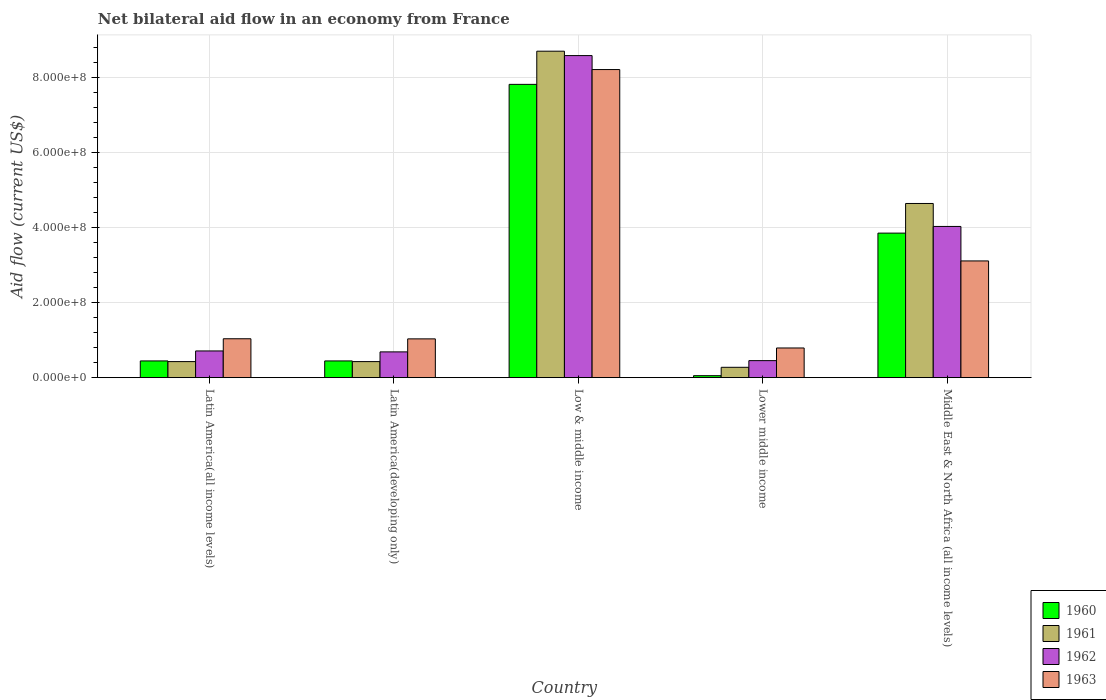How many groups of bars are there?
Offer a terse response. 5. How many bars are there on the 3rd tick from the left?
Offer a terse response. 4. How many bars are there on the 2nd tick from the right?
Your response must be concise. 4. What is the label of the 1st group of bars from the left?
Provide a succinct answer. Latin America(all income levels). In how many cases, is the number of bars for a given country not equal to the number of legend labels?
Provide a short and direct response. 0. What is the net bilateral aid flow in 1962 in Latin America(all income levels)?
Provide a succinct answer. 7.12e+07. Across all countries, what is the maximum net bilateral aid flow in 1960?
Give a very brief answer. 7.82e+08. Across all countries, what is the minimum net bilateral aid flow in 1962?
Provide a short and direct response. 4.54e+07. In which country was the net bilateral aid flow in 1960 maximum?
Offer a terse response. Low & middle income. In which country was the net bilateral aid flow in 1960 minimum?
Provide a short and direct response. Lower middle income. What is the total net bilateral aid flow in 1961 in the graph?
Offer a very short reply. 1.45e+09. What is the difference between the net bilateral aid flow in 1960 in Lower middle income and that in Middle East & North Africa (all income levels)?
Your answer should be compact. -3.80e+08. What is the difference between the net bilateral aid flow in 1963 in Low & middle income and the net bilateral aid flow in 1961 in Middle East & North Africa (all income levels)?
Offer a terse response. 3.57e+08. What is the average net bilateral aid flow in 1960 per country?
Make the answer very short. 2.52e+08. What is the difference between the net bilateral aid flow of/in 1963 and net bilateral aid flow of/in 1960 in Latin America(all income levels)?
Your response must be concise. 5.91e+07. What is the ratio of the net bilateral aid flow in 1961 in Latin America(developing only) to that in Middle East & North Africa (all income levels)?
Your answer should be very brief. 0.09. What is the difference between the highest and the second highest net bilateral aid flow in 1960?
Offer a terse response. 3.96e+08. What is the difference between the highest and the lowest net bilateral aid flow in 1963?
Your answer should be compact. 7.42e+08. In how many countries, is the net bilateral aid flow in 1962 greater than the average net bilateral aid flow in 1962 taken over all countries?
Make the answer very short. 2. Is the sum of the net bilateral aid flow in 1961 in Low & middle income and Middle East & North Africa (all income levels) greater than the maximum net bilateral aid flow in 1960 across all countries?
Ensure brevity in your answer.  Yes. Is it the case that in every country, the sum of the net bilateral aid flow in 1961 and net bilateral aid flow in 1960 is greater than the sum of net bilateral aid flow in 1962 and net bilateral aid flow in 1963?
Provide a succinct answer. No. What does the 3rd bar from the left in Lower middle income represents?
Your response must be concise. 1962. Are all the bars in the graph horizontal?
Offer a terse response. No. How many countries are there in the graph?
Give a very brief answer. 5. What is the difference between two consecutive major ticks on the Y-axis?
Your response must be concise. 2.00e+08. Does the graph contain any zero values?
Provide a succinct answer. No. Where does the legend appear in the graph?
Ensure brevity in your answer.  Bottom right. How are the legend labels stacked?
Offer a terse response. Vertical. What is the title of the graph?
Offer a terse response. Net bilateral aid flow in an economy from France. What is the Aid flow (current US$) of 1960 in Latin America(all income levels)?
Offer a terse response. 4.46e+07. What is the Aid flow (current US$) of 1961 in Latin America(all income levels)?
Your answer should be compact. 4.28e+07. What is the Aid flow (current US$) of 1962 in Latin America(all income levels)?
Your response must be concise. 7.12e+07. What is the Aid flow (current US$) in 1963 in Latin America(all income levels)?
Offer a very short reply. 1.04e+08. What is the Aid flow (current US$) of 1960 in Latin America(developing only)?
Give a very brief answer. 4.46e+07. What is the Aid flow (current US$) of 1961 in Latin America(developing only)?
Offer a terse response. 4.28e+07. What is the Aid flow (current US$) in 1962 in Latin America(developing only)?
Make the answer very short. 6.87e+07. What is the Aid flow (current US$) in 1963 in Latin America(developing only)?
Keep it short and to the point. 1.03e+08. What is the Aid flow (current US$) in 1960 in Low & middle income?
Provide a short and direct response. 7.82e+08. What is the Aid flow (current US$) in 1961 in Low & middle income?
Provide a short and direct response. 8.70e+08. What is the Aid flow (current US$) of 1962 in Low & middle income?
Provide a succinct answer. 8.58e+08. What is the Aid flow (current US$) in 1963 in Low & middle income?
Provide a succinct answer. 8.21e+08. What is the Aid flow (current US$) in 1960 in Lower middle income?
Give a very brief answer. 5.30e+06. What is the Aid flow (current US$) of 1961 in Lower middle income?
Your answer should be compact. 2.76e+07. What is the Aid flow (current US$) in 1962 in Lower middle income?
Offer a very short reply. 4.54e+07. What is the Aid flow (current US$) in 1963 in Lower middle income?
Your response must be concise. 7.91e+07. What is the Aid flow (current US$) in 1960 in Middle East & North Africa (all income levels)?
Provide a short and direct response. 3.85e+08. What is the Aid flow (current US$) in 1961 in Middle East & North Africa (all income levels)?
Keep it short and to the point. 4.64e+08. What is the Aid flow (current US$) in 1962 in Middle East & North Africa (all income levels)?
Your answer should be very brief. 4.03e+08. What is the Aid flow (current US$) in 1963 in Middle East & North Africa (all income levels)?
Offer a terse response. 3.11e+08. Across all countries, what is the maximum Aid flow (current US$) in 1960?
Give a very brief answer. 7.82e+08. Across all countries, what is the maximum Aid flow (current US$) in 1961?
Make the answer very short. 8.70e+08. Across all countries, what is the maximum Aid flow (current US$) in 1962?
Give a very brief answer. 8.58e+08. Across all countries, what is the maximum Aid flow (current US$) in 1963?
Ensure brevity in your answer.  8.21e+08. Across all countries, what is the minimum Aid flow (current US$) in 1960?
Keep it short and to the point. 5.30e+06. Across all countries, what is the minimum Aid flow (current US$) in 1961?
Provide a short and direct response. 2.76e+07. Across all countries, what is the minimum Aid flow (current US$) in 1962?
Provide a short and direct response. 4.54e+07. Across all countries, what is the minimum Aid flow (current US$) in 1963?
Offer a terse response. 7.91e+07. What is the total Aid flow (current US$) of 1960 in the graph?
Offer a terse response. 1.26e+09. What is the total Aid flow (current US$) in 1961 in the graph?
Your answer should be compact. 1.45e+09. What is the total Aid flow (current US$) in 1962 in the graph?
Your response must be concise. 1.45e+09. What is the total Aid flow (current US$) in 1963 in the graph?
Your answer should be compact. 1.42e+09. What is the difference between the Aid flow (current US$) in 1960 in Latin America(all income levels) and that in Latin America(developing only)?
Your response must be concise. 0. What is the difference between the Aid flow (current US$) of 1961 in Latin America(all income levels) and that in Latin America(developing only)?
Your response must be concise. 0. What is the difference between the Aid flow (current US$) in 1962 in Latin America(all income levels) and that in Latin America(developing only)?
Your response must be concise. 2.50e+06. What is the difference between the Aid flow (current US$) of 1960 in Latin America(all income levels) and that in Low & middle income?
Your answer should be compact. -7.37e+08. What is the difference between the Aid flow (current US$) of 1961 in Latin America(all income levels) and that in Low & middle income?
Provide a succinct answer. -8.27e+08. What is the difference between the Aid flow (current US$) in 1962 in Latin America(all income levels) and that in Low & middle income?
Make the answer very short. -7.87e+08. What is the difference between the Aid flow (current US$) of 1963 in Latin America(all income levels) and that in Low & middle income?
Provide a short and direct response. -7.17e+08. What is the difference between the Aid flow (current US$) of 1960 in Latin America(all income levels) and that in Lower middle income?
Ensure brevity in your answer.  3.93e+07. What is the difference between the Aid flow (current US$) in 1961 in Latin America(all income levels) and that in Lower middle income?
Make the answer very short. 1.52e+07. What is the difference between the Aid flow (current US$) of 1962 in Latin America(all income levels) and that in Lower middle income?
Ensure brevity in your answer.  2.58e+07. What is the difference between the Aid flow (current US$) in 1963 in Latin America(all income levels) and that in Lower middle income?
Your answer should be very brief. 2.46e+07. What is the difference between the Aid flow (current US$) of 1960 in Latin America(all income levels) and that in Middle East & North Africa (all income levels)?
Your answer should be very brief. -3.41e+08. What is the difference between the Aid flow (current US$) of 1961 in Latin America(all income levels) and that in Middle East & North Africa (all income levels)?
Offer a very short reply. -4.21e+08. What is the difference between the Aid flow (current US$) of 1962 in Latin America(all income levels) and that in Middle East & North Africa (all income levels)?
Your answer should be compact. -3.32e+08. What is the difference between the Aid flow (current US$) in 1963 in Latin America(all income levels) and that in Middle East & North Africa (all income levels)?
Your answer should be compact. -2.07e+08. What is the difference between the Aid flow (current US$) in 1960 in Latin America(developing only) and that in Low & middle income?
Your answer should be compact. -7.37e+08. What is the difference between the Aid flow (current US$) in 1961 in Latin America(developing only) and that in Low & middle income?
Ensure brevity in your answer.  -8.27e+08. What is the difference between the Aid flow (current US$) in 1962 in Latin America(developing only) and that in Low & middle income?
Offer a very short reply. -7.90e+08. What is the difference between the Aid flow (current US$) in 1963 in Latin America(developing only) and that in Low & middle income?
Your answer should be very brief. -7.18e+08. What is the difference between the Aid flow (current US$) in 1960 in Latin America(developing only) and that in Lower middle income?
Give a very brief answer. 3.93e+07. What is the difference between the Aid flow (current US$) in 1961 in Latin America(developing only) and that in Lower middle income?
Your answer should be compact. 1.52e+07. What is the difference between the Aid flow (current US$) in 1962 in Latin America(developing only) and that in Lower middle income?
Provide a succinct answer. 2.33e+07. What is the difference between the Aid flow (current US$) in 1963 in Latin America(developing only) and that in Lower middle income?
Give a very brief answer. 2.43e+07. What is the difference between the Aid flow (current US$) in 1960 in Latin America(developing only) and that in Middle East & North Africa (all income levels)?
Provide a short and direct response. -3.41e+08. What is the difference between the Aid flow (current US$) in 1961 in Latin America(developing only) and that in Middle East & North Africa (all income levels)?
Make the answer very short. -4.21e+08. What is the difference between the Aid flow (current US$) in 1962 in Latin America(developing only) and that in Middle East & North Africa (all income levels)?
Your answer should be compact. -3.34e+08. What is the difference between the Aid flow (current US$) of 1963 in Latin America(developing only) and that in Middle East & North Africa (all income levels)?
Offer a terse response. -2.08e+08. What is the difference between the Aid flow (current US$) of 1960 in Low & middle income and that in Lower middle income?
Offer a terse response. 7.76e+08. What is the difference between the Aid flow (current US$) in 1961 in Low & middle income and that in Lower middle income?
Offer a very short reply. 8.42e+08. What is the difference between the Aid flow (current US$) in 1962 in Low & middle income and that in Lower middle income?
Your answer should be very brief. 8.13e+08. What is the difference between the Aid flow (current US$) in 1963 in Low & middle income and that in Lower middle income?
Ensure brevity in your answer.  7.42e+08. What is the difference between the Aid flow (current US$) in 1960 in Low & middle income and that in Middle East & North Africa (all income levels)?
Provide a short and direct response. 3.96e+08. What is the difference between the Aid flow (current US$) in 1961 in Low & middle income and that in Middle East & North Africa (all income levels)?
Make the answer very short. 4.06e+08. What is the difference between the Aid flow (current US$) in 1962 in Low & middle income and that in Middle East & North Africa (all income levels)?
Give a very brief answer. 4.55e+08. What is the difference between the Aid flow (current US$) of 1963 in Low & middle income and that in Middle East & North Africa (all income levels)?
Provide a succinct answer. 5.10e+08. What is the difference between the Aid flow (current US$) of 1960 in Lower middle income and that in Middle East & North Africa (all income levels)?
Provide a short and direct response. -3.80e+08. What is the difference between the Aid flow (current US$) in 1961 in Lower middle income and that in Middle East & North Africa (all income levels)?
Offer a very short reply. -4.37e+08. What is the difference between the Aid flow (current US$) in 1962 in Lower middle income and that in Middle East & North Africa (all income levels)?
Your response must be concise. -3.58e+08. What is the difference between the Aid flow (current US$) in 1963 in Lower middle income and that in Middle East & North Africa (all income levels)?
Your answer should be compact. -2.32e+08. What is the difference between the Aid flow (current US$) in 1960 in Latin America(all income levels) and the Aid flow (current US$) in 1961 in Latin America(developing only)?
Provide a succinct answer. 1.80e+06. What is the difference between the Aid flow (current US$) of 1960 in Latin America(all income levels) and the Aid flow (current US$) of 1962 in Latin America(developing only)?
Your answer should be very brief. -2.41e+07. What is the difference between the Aid flow (current US$) in 1960 in Latin America(all income levels) and the Aid flow (current US$) in 1963 in Latin America(developing only)?
Your answer should be compact. -5.88e+07. What is the difference between the Aid flow (current US$) in 1961 in Latin America(all income levels) and the Aid flow (current US$) in 1962 in Latin America(developing only)?
Ensure brevity in your answer.  -2.59e+07. What is the difference between the Aid flow (current US$) in 1961 in Latin America(all income levels) and the Aid flow (current US$) in 1963 in Latin America(developing only)?
Make the answer very short. -6.06e+07. What is the difference between the Aid flow (current US$) in 1962 in Latin America(all income levels) and the Aid flow (current US$) in 1963 in Latin America(developing only)?
Keep it short and to the point. -3.22e+07. What is the difference between the Aid flow (current US$) in 1960 in Latin America(all income levels) and the Aid flow (current US$) in 1961 in Low & middle income?
Your answer should be very brief. -8.25e+08. What is the difference between the Aid flow (current US$) of 1960 in Latin America(all income levels) and the Aid flow (current US$) of 1962 in Low & middle income?
Keep it short and to the point. -8.14e+08. What is the difference between the Aid flow (current US$) of 1960 in Latin America(all income levels) and the Aid flow (current US$) of 1963 in Low & middle income?
Provide a succinct answer. -7.76e+08. What is the difference between the Aid flow (current US$) in 1961 in Latin America(all income levels) and the Aid flow (current US$) in 1962 in Low & middle income?
Keep it short and to the point. -8.16e+08. What is the difference between the Aid flow (current US$) in 1961 in Latin America(all income levels) and the Aid flow (current US$) in 1963 in Low & middle income?
Provide a short and direct response. -7.78e+08. What is the difference between the Aid flow (current US$) in 1962 in Latin America(all income levels) and the Aid flow (current US$) in 1963 in Low & middle income?
Give a very brief answer. -7.50e+08. What is the difference between the Aid flow (current US$) of 1960 in Latin America(all income levels) and the Aid flow (current US$) of 1961 in Lower middle income?
Your response must be concise. 1.70e+07. What is the difference between the Aid flow (current US$) in 1960 in Latin America(all income levels) and the Aid flow (current US$) in 1962 in Lower middle income?
Make the answer very short. -8.00e+05. What is the difference between the Aid flow (current US$) of 1960 in Latin America(all income levels) and the Aid flow (current US$) of 1963 in Lower middle income?
Provide a short and direct response. -3.45e+07. What is the difference between the Aid flow (current US$) in 1961 in Latin America(all income levels) and the Aid flow (current US$) in 1962 in Lower middle income?
Offer a very short reply. -2.60e+06. What is the difference between the Aid flow (current US$) of 1961 in Latin America(all income levels) and the Aid flow (current US$) of 1963 in Lower middle income?
Your response must be concise. -3.63e+07. What is the difference between the Aid flow (current US$) of 1962 in Latin America(all income levels) and the Aid flow (current US$) of 1963 in Lower middle income?
Keep it short and to the point. -7.90e+06. What is the difference between the Aid flow (current US$) of 1960 in Latin America(all income levels) and the Aid flow (current US$) of 1961 in Middle East & North Africa (all income levels)?
Keep it short and to the point. -4.20e+08. What is the difference between the Aid flow (current US$) in 1960 in Latin America(all income levels) and the Aid flow (current US$) in 1962 in Middle East & North Africa (all income levels)?
Make the answer very short. -3.58e+08. What is the difference between the Aid flow (current US$) of 1960 in Latin America(all income levels) and the Aid flow (current US$) of 1963 in Middle East & North Africa (all income levels)?
Make the answer very short. -2.66e+08. What is the difference between the Aid flow (current US$) of 1961 in Latin America(all income levels) and the Aid flow (current US$) of 1962 in Middle East & North Africa (all income levels)?
Offer a terse response. -3.60e+08. What is the difference between the Aid flow (current US$) of 1961 in Latin America(all income levels) and the Aid flow (current US$) of 1963 in Middle East & North Africa (all income levels)?
Provide a short and direct response. -2.68e+08. What is the difference between the Aid flow (current US$) in 1962 in Latin America(all income levels) and the Aid flow (current US$) in 1963 in Middle East & North Africa (all income levels)?
Offer a terse response. -2.40e+08. What is the difference between the Aid flow (current US$) in 1960 in Latin America(developing only) and the Aid flow (current US$) in 1961 in Low & middle income?
Give a very brief answer. -8.25e+08. What is the difference between the Aid flow (current US$) of 1960 in Latin America(developing only) and the Aid flow (current US$) of 1962 in Low & middle income?
Offer a very short reply. -8.14e+08. What is the difference between the Aid flow (current US$) in 1960 in Latin America(developing only) and the Aid flow (current US$) in 1963 in Low & middle income?
Offer a terse response. -7.76e+08. What is the difference between the Aid flow (current US$) in 1961 in Latin America(developing only) and the Aid flow (current US$) in 1962 in Low & middle income?
Keep it short and to the point. -8.16e+08. What is the difference between the Aid flow (current US$) of 1961 in Latin America(developing only) and the Aid flow (current US$) of 1963 in Low & middle income?
Your answer should be very brief. -7.78e+08. What is the difference between the Aid flow (current US$) in 1962 in Latin America(developing only) and the Aid flow (current US$) in 1963 in Low & middle income?
Your answer should be very brief. -7.52e+08. What is the difference between the Aid flow (current US$) of 1960 in Latin America(developing only) and the Aid flow (current US$) of 1961 in Lower middle income?
Provide a succinct answer. 1.70e+07. What is the difference between the Aid flow (current US$) of 1960 in Latin America(developing only) and the Aid flow (current US$) of 1962 in Lower middle income?
Keep it short and to the point. -8.00e+05. What is the difference between the Aid flow (current US$) of 1960 in Latin America(developing only) and the Aid flow (current US$) of 1963 in Lower middle income?
Your answer should be very brief. -3.45e+07. What is the difference between the Aid flow (current US$) of 1961 in Latin America(developing only) and the Aid flow (current US$) of 1962 in Lower middle income?
Provide a succinct answer. -2.60e+06. What is the difference between the Aid flow (current US$) of 1961 in Latin America(developing only) and the Aid flow (current US$) of 1963 in Lower middle income?
Ensure brevity in your answer.  -3.63e+07. What is the difference between the Aid flow (current US$) of 1962 in Latin America(developing only) and the Aid flow (current US$) of 1963 in Lower middle income?
Your answer should be very brief. -1.04e+07. What is the difference between the Aid flow (current US$) of 1960 in Latin America(developing only) and the Aid flow (current US$) of 1961 in Middle East & North Africa (all income levels)?
Offer a very short reply. -4.20e+08. What is the difference between the Aid flow (current US$) in 1960 in Latin America(developing only) and the Aid flow (current US$) in 1962 in Middle East & North Africa (all income levels)?
Keep it short and to the point. -3.58e+08. What is the difference between the Aid flow (current US$) of 1960 in Latin America(developing only) and the Aid flow (current US$) of 1963 in Middle East & North Africa (all income levels)?
Give a very brief answer. -2.66e+08. What is the difference between the Aid flow (current US$) in 1961 in Latin America(developing only) and the Aid flow (current US$) in 1962 in Middle East & North Africa (all income levels)?
Your answer should be very brief. -3.60e+08. What is the difference between the Aid flow (current US$) of 1961 in Latin America(developing only) and the Aid flow (current US$) of 1963 in Middle East & North Africa (all income levels)?
Provide a succinct answer. -2.68e+08. What is the difference between the Aid flow (current US$) of 1962 in Latin America(developing only) and the Aid flow (current US$) of 1963 in Middle East & North Africa (all income levels)?
Ensure brevity in your answer.  -2.42e+08. What is the difference between the Aid flow (current US$) of 1960 in Low & middle income and the Aid flow (current US$) of 1961 in Lower middle income?
Your response must be concise. 7.54e+08. What is the difference between the Aid flow (current US$) in 1960 in Low & middle income and the Aid flow (current US$) in 1962 in Lower middle income?
Give a very brief answer. 7.36e+08. What is the difference between the Aid flow (current US$) in 1960 in Low & middle income and the Aid flow (current US$) in 1963 in Lower middle income?
Your response must be concise. 7.02e+08. What is the difference between the Aid flow (current US$) in 1961 in Low & middle income and the Aid flow (current US$) in 1962 in Lower middle income?
Your response must be concise. 8.25e+08. What is the difference between the Aid flow (current US$) of 1961 in Low & middle income and the Aid flow (current US$) of 1963 in Lower middle income?
Offer a very short reply. 7.91e+08. What is the difference between the Aid flow (current US$) of 1962 in Low & middle income and the Aid flow (current US$) of 1963 in Lower middle income?
Keep it short and to the point. 7.79e+08. What is the difference between the Aid flow (current US$) in 1960 in Low & middle income and the Aid flow (current US$) in 1961 in Middle East & North Africa (all income levels)?
Provide a succinct answer. 3.17e+08. What is the difference between the Aid flow (current US$) in 1960 in Low & middle income and the Aid flow (current US$) in 1962 in Middle East & North Africa (all income levels)?
Offer a very short reply. 3.79e+08. What is the difference between the Aid flow (current US$) of 1960 in Low & middle income and the Aid flow (current US$) of 1963 in Middle East & North Africa (all income levels)?
Your answer should be compact. 4.70e+08. What is the difference between the Aid flow (current US$) in 1961 in Low & middle income and the Aid flow (current US$) in 1962 in Middle East & North Africa (all income levels)?
Your response must be concise. 4.67e+08. What is the difference between the Aid flow (current US$) in 1961 in Low & middle income and the Aid flow (current US$) in 1963 in Middle East & North Africa (all income levels)?
Offer a very short reply. 5.59e+08. What is the difference between the Aid flow (current US$) of 1962 in Low & middle income and the Aid flow (current US$) of 1963 in Middle East & North Africa (all income levels)?
Your response must be concise. 5.47e+08. What is the difference between the Aid flow (current US$) of 1960 in Lower middle income and the Aid flow (current US$) of 1961 in Middle East & North Africa (all income levels)?
Ensure brevity in your answer.  -4.59e+08. What is the difference between the Aid flow (current US$) of 1960 in Lower middle income and the Aid flow (current US$) of 1962 in Middle East & North Africa (all income levels)?
Ensure brevity in your answer.  -3.98e+08. What is the difference between the Aid flow (current US$) of 1960 in Lower middle income and the Aid flow (current US$) of 1963 in Middle East & North Africa (all income levels)?
Provide a short and direct response. -3.06e+08. What is the difference between the Aid flow (current US$) of 1961 in Lower middle income and the Aid flow (current US$) of 1962 in Middle East & North Africa (all income levels)?
Your answer should be very brief. -3.75e+08. What is the difference between the Aid flow (current US$) in 1961 in Lower middle income and the Aid flow (current US$) in 1963 in Middle East & North Africa (all income levels)?
Offer a terse response. -2.84e+08. What is the difference between the Aid flow (current US$) of 1962 in Lower middle income and the Aid flow (current US$) of 1963 in Middle East & North Africa (all income levels)?
Give a very brief answer. -2.66e+08. What is the average Aid flow (current US$) of 1960 per country?
Your answer should be very brief. 2.52e+08. What is the average Aid flow (current US$) of 1961 per country?
Provide a succinct answer. 2.89e+08. What is the average Aid flow (current US$) in 1962 per country?
Provide a short and direct response. 2.89e+08. What is the average Aid flow (current US$) in 1963 per country?
Provide a succinct answer. 2.84e+08. What is the difference between the Aid flow (current US$) in 1960 and Aid flow (current US$) in 1961 in Latin America(all income levels)?
Keep it short and to the point. 1.80e+06. What is the difference between the Aid flow (current US$) of 1960 and Aid flow (current US$) of 1962 in Latin America(all income levels)?
Your answer should be very brief. -2.66e+07. What is the difference between the Aid flow (current US$) in 1960 and Aid flow (current US$) in 1963 in Latin America(all income levels)?
Your response must be concise. -5.91e+07. What is the difference between the Aid flow (current US$) of 1961 and Aid flow (current US$) of 1962 in Latin America(all income levels)?
Ensure brevity in your answer.  -2.84e+07. What is the difference between the Aid flow (current US$) in 1961 and Aid flow (current US$) in 1963 in Latin America(all income levels)?
Ensure brevity in your answer.  -6.09e+07. What is the difference between the Aid flow (current US$) of 1962 and Aid flow (current US$) of 1963 in Latin America(all income levels)?
Your response must be concise. -3.25e+07. What is the difference between the Aid flow (current US$) in 1960 and Aid flow (current US$) in 1961 in Latin America(developing only)?
Give a very brief answer. 1.80e+06. What is the difference between the Aid flow (current US$) in 1960 and Aid flow (current US$) in 1962 in Latin America(developing only)?
Make the answer very short. -2.41e+07. What is the difference between the Aid flow (current US$) in 1960 and Aid flow (current US$) in 1963 in Latin America(developing only)?
Provide a short and direct response. -5.88e+07. What is the difference between the Aid flow (current US$) of 1961 and Aid flow (current US$) of 1962 in Latin America(developing only)?
Your response must be concise. -2.59e+07. What is the difference between the Aid flow (current US$) in 1961 and Aid flow (current US$) in 1963 in Latin America(developing only)?
Give a very brief answer. -6.06e+07. What is the difference between the Aid flow (current US$) in 1962 and Aid flow (current US$) in 1963 in Latin America(developing only)?
Provide a succinct answer. -3.47e+07. What is the difference between the Aid flow (current US$) of 1960 and Aid flow (current US$) of 1961 in Low & middle income?
Make the answer very short. -8.84e+07. What is the difference between the Aid flow (current US$) of 1960 and Aid flow (current US$) of 1962 in Low & middle income?
Provide a short and direct response. -7.67e+07. What is the difference between the Aid flow (current US$) of 1960 and Aid flow (current US$) of 1963 in Low & middle income?
Your answer should be compact. -3.95e+07. What is the difference between the Aid flow (current US$) in 1961 and Aid flow (current US$) in 1962 in Low & middle income?
Your answer should be compact. 1.17e+07. What is the difference between the Aid flow (current US$) in 1961 and Aid flow (current US$) in 1963 in Low & middle income?
Give a very brief answer. 4.89e+07. What is the difference between the Aid flow (current US$) in 1962 and Aid flow (current US$) in 1963 in Low & middle income?
Your response must be concise. 3.72e+07. What is the difference between the Aid flow (current US$) of 1960 and Aid flow (current US$) of 1961 in Lower middle income?
Your response must be concise. -2.23e+07. What is the difference between the Aid flow (current US$) in 1960 and Aid flow (current US$) in 1962 in Lower middle income?
Provide a succinct answer. -4.01e+07. What is the difference between the Aid flow (current US$) of 1960 and Aid flow (current US$) of 1963 in Lower middle income?
Offer a very short reply. -7.38e+07. What is the difference between the Aid flow (current US$) in 1961 and Aid flow (current US$) in 1962 in Lower middle income?
Your response must be concise. -1.78e+07. What is the difference between the Aid flow (current US$) of 1961 and Aid flow (current US$) of 1963 in Lower middle income?
Your answer should be very brief. -5.15e+07. What is the difference between the Aid flow (current US$) in 1962 and Aid flow (current US$) in 1963 in Lower middle income?
Make the answer very short. -3.37e+07. What is the difference between the Aid flow (current US$) in 1960 and Aid flow (current US$) in 1961 in Middle East & North Africa (all income levels)?
Provide a succinct answer. -7.90e+07. What is the difference between the Aid flow (current US$) of 1960 and Aid flow (current US$) of 1962 in Middle East & North Africa (all income levels)?
Offer a terse response. -1.78e+07. What is the difference between the Aid flow (current US$) of 1960 and Aid flow (current US$) of 1963 in Middle East & North Africa (all income levels)?
Offer a terse response. 7.41e+07. What is the difference between the Aid flow (current US$) of 1961 and Aid flow (current US$) of 1962 in Middle East & North Africa (all income levels)?
Keep it short and to the point. 6.12e+07. What is the difference between the Aid flow (current US$) in 1961 and Aid flow (current US$) in 1963 in Middle East & North Africa (all income levels)?
Your response must be concise. 1.53e+08. What is the difference between the Aid flow (current US$) of 1962 and Aid flow (current US$) of 1963 in Middle East & North Africa (all income levels)?
Keep it short and to the point. 9.19e+07. What is the ratio of the Aid flow (current US$) in 1962 in Latin America(all income levels) to that in Latin America(developing only)?
Your answer should be compact. 1.04. What is the ratio of the Aid flow (current US$) in 1960 in Latin America(all income levels) to that in Low & middle income?
Ensure brevity in your answer.  0.06. What is the ratio of the Aid flow (current US$) in 1961 in Latin America(all income levels) to that in Low & middle income?
Give a very brief answer. 0.05. What is the ratio of the Aid flow (current US$) of 1962 in Latin America(all income levels) to that in Low & middle income?
Provide a succinct answer. 0.08. What is the ratio of the Aid flow (current US$) of 1963 in Latin America(all income levels) to that in Low & middle income?
Make the answer very short. 0.13. What is the ratio of the Aid flow (current US$) in 1960 in Latin America(all income levels) to that in Lower middle income?
Your answer should be very brief. 8.42. What is the ratio of the Aid flow (current US$) in 1961 in Latin America(all income levels) to that in Lower middle income?
Give a very brief answer. 1.55. What is the ratio of the Aid flow (current US$) in 1962 in Latin America(all income levels) to that in Lower middle income?
Keep it short and to the point. 1.57. What is the ratio of the Aid flow (current US$) of 1963 in Latin America(all income levels) to that in Lower middle income?
Provide a short and direct response. 1.31. What is the ratio of the Aid flow (current US$) in 1960 in Latin America(all income levels) to that in Middle East & North Africa (all income levels)?
Your response must be concise. 0.12. What is the ratio of the Aid flow (current US$) of 1961 in Latin America(all income levels) to that in Middle East & North Africa (all income levels)?
Keep it short and to the point. 0.09. What is the ratio of the Aid flow (current US$) of 1962 in Latin America(all income levels) to that in Middle East & North Africa (all income levels)?
Provide a succinct answer. 0.18. What is the ratio of the Aid flow (current US$) in 1963 in Latin America(all income levels) to that in Middle East & North Africa (all income levels)?
Offer a terse response. 0.33. What is the ratio of the Aid flow (current US$) of 1960 in Latin America(developing only) to that in Low & middle income?
Offer a very short reply. 0.06. What is the ratio of the Aid flow (current US$) in 1961 in Latin America(developing only) to that in Low & middle income?
Your response must be concise. 0.05. What is the ratio of the Aid flow (current US$) in 1963 in Latin America(developing only) to that in Low & middle income?
Offer a terse response. 0.13. What is the ratio of the Aid flow (current US$) in 1960 in Latin America(developing only) to that in Lower middle income?
Your answer should be compact. 8.42. What is the ratio of the Aid flow (current US$) of 1961 in Latin America(developing only) to that in Lower middle income?
Offer a very short reply. 1.55. What is the ratio of the Aid flow (current US$) in 1962 in Latin America(developing only) to that in Lower middle income?
Your response must be concise. 1.51. What is the ratio of the Aid flow (current US$) of 1963 in Latin America(developing only) to that in Lower middle income?
Offer a very short reply. 1.31. What is the ratio of the Aid flow (current US$) of 1960 in Latin America(developing only) to that in Middle East & North Africa (all income levels)?
Offer a very short reply. 0.12. What is the ratio of the Aid flow (current US$) of 1961 in Latin America(developing only) to that in Middle East & North Africa (all income levels)?
Offer a very short reply. 0.09. What is the ratio of the Aid flow (current US$) of 1962 in Latin America(developing only) to that in Middle East & North Africa (all income levels)?
Your answer should be very brief. 0.17. What is the ratio of the Aid flow (current US$) in 1963 in Latin America(developing only) to that in Middle East & North Africa (all income levels)?
Offer a terse response. 0.33. What is the ratio of the Aid flow (current US$) of 1960 in Low & middle income to that in Lower middle income?
Provide a short and direct response. 147.47. What is the ratio of the Aid flow (current US$) in 1961 in Low & middle income to that in Lower middle income?
Your response must be concise. 31.52. What is the ratio of the Aid flow (current US$) of 1962 in Low & middle income to that in Lower middle income?
Give a very brief answer. 18.91. What is the ratio of the Aid flow (current US$) of 1963 in Low & middle income to that in Lower middle income?
Your answer should be compact. 10.38. What is the ratio of the Aid flow (current US$) of 1960 in Low & middle income to that in Middle East & North Africa (all income levels)?
Offer a very short reply. 2.03. What is the ratio of the Aid flow (current US$) in 1961 in Low & middle income to that in Middle East & North Africa (all income levels)?
Make the answer very short. 1.87. What is the ratio of the Aid flow (current US$) of 1962 in Low & middle income to that in Middle East & North Africa (all income levels)?
Your answer should be compact. 2.13. What is the ratio of the Aid flow (current US$) of 1963 in Low & middle income to that in Middle East & North Africa (all income levels)?
Keep it short and to the point. 2.64. What is the ratio of the Aid flow (current US$) of 1960 in Lower middle income to that in Middle East & North Africa (all income levels)?
Your answer should be compact. 0.01. What is the ratio of the Aid flow (current US$) of 1961 in Lower middle income to that in Middle East & North Africa (all income levels)?
Provide a succinct answer. 0.06. What is the ratio of the Aid flow (current US$) in 1962 in Lower middle income to that in Middle East & North Africa (all income levels)?
Offer a terse response. 0.11. What is the ratio of the Aid flow (current US$) in 1963 in Lower middle income to that in Middle East & North Africa (all income levels)?
Offer a terse response. 0.25. What is the difference between the highest and the second highest Aid flow (current US$) in 1960?
Provide a short and direct response. 3.96e+08. What is the difference between the highest and the second highest Aid flow (current US$) in 1961?
Your answer should be compact. 4.06e+08. What is the difference between the highest and the second highest Aid flow (current US$) in 1962?
Ensure brevity in your answer.  4.55e+08. What is the difference between the highest and the second highest Aid flow (current US$) in 1963?
Ensure brevity in your answer.  5.10e+08. What is the difference between the highest and the lowest Aid flow (current US$) in 1960?
Your response must be concise. 7.76e+08. What is the difference between the highest and the lowest Aid flow (current US$) of 1961?
Make the answer very short. 8.42e+08. What is the difference between the highest and the lowest Aid flow (current US$) of 1962?
Offer a terse response. 8.13e+08. What is the difference between the highest and the lowest Aid flow (current US$) of 1963?
Offer a terse response. 7.42e+08. 